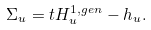Convert formula to latex. <formula><loc_0><loc_0><loc_500><loc_500>\Sigma _ { u } = t H _ { u } ^ { 1 , g e n } - h _ { u } .</formula> 